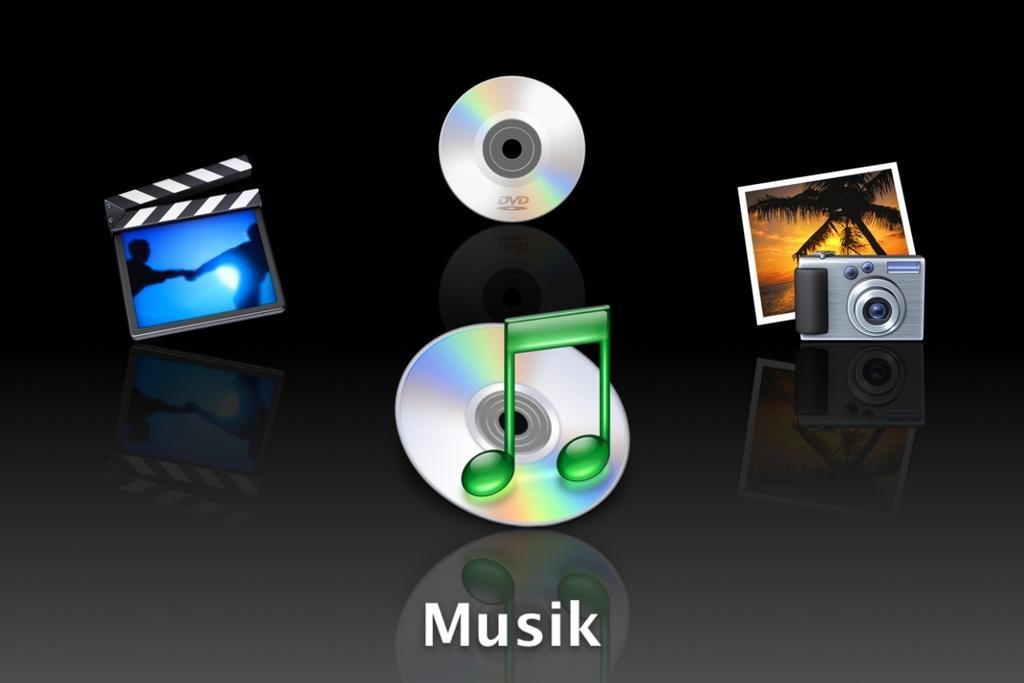In one or two sentences, can you explain what this image depicts? In this image I can see depiction picture where I can see two disks, a photo, a camera and few other things. I can also see something is written on the bottom side of this image. 